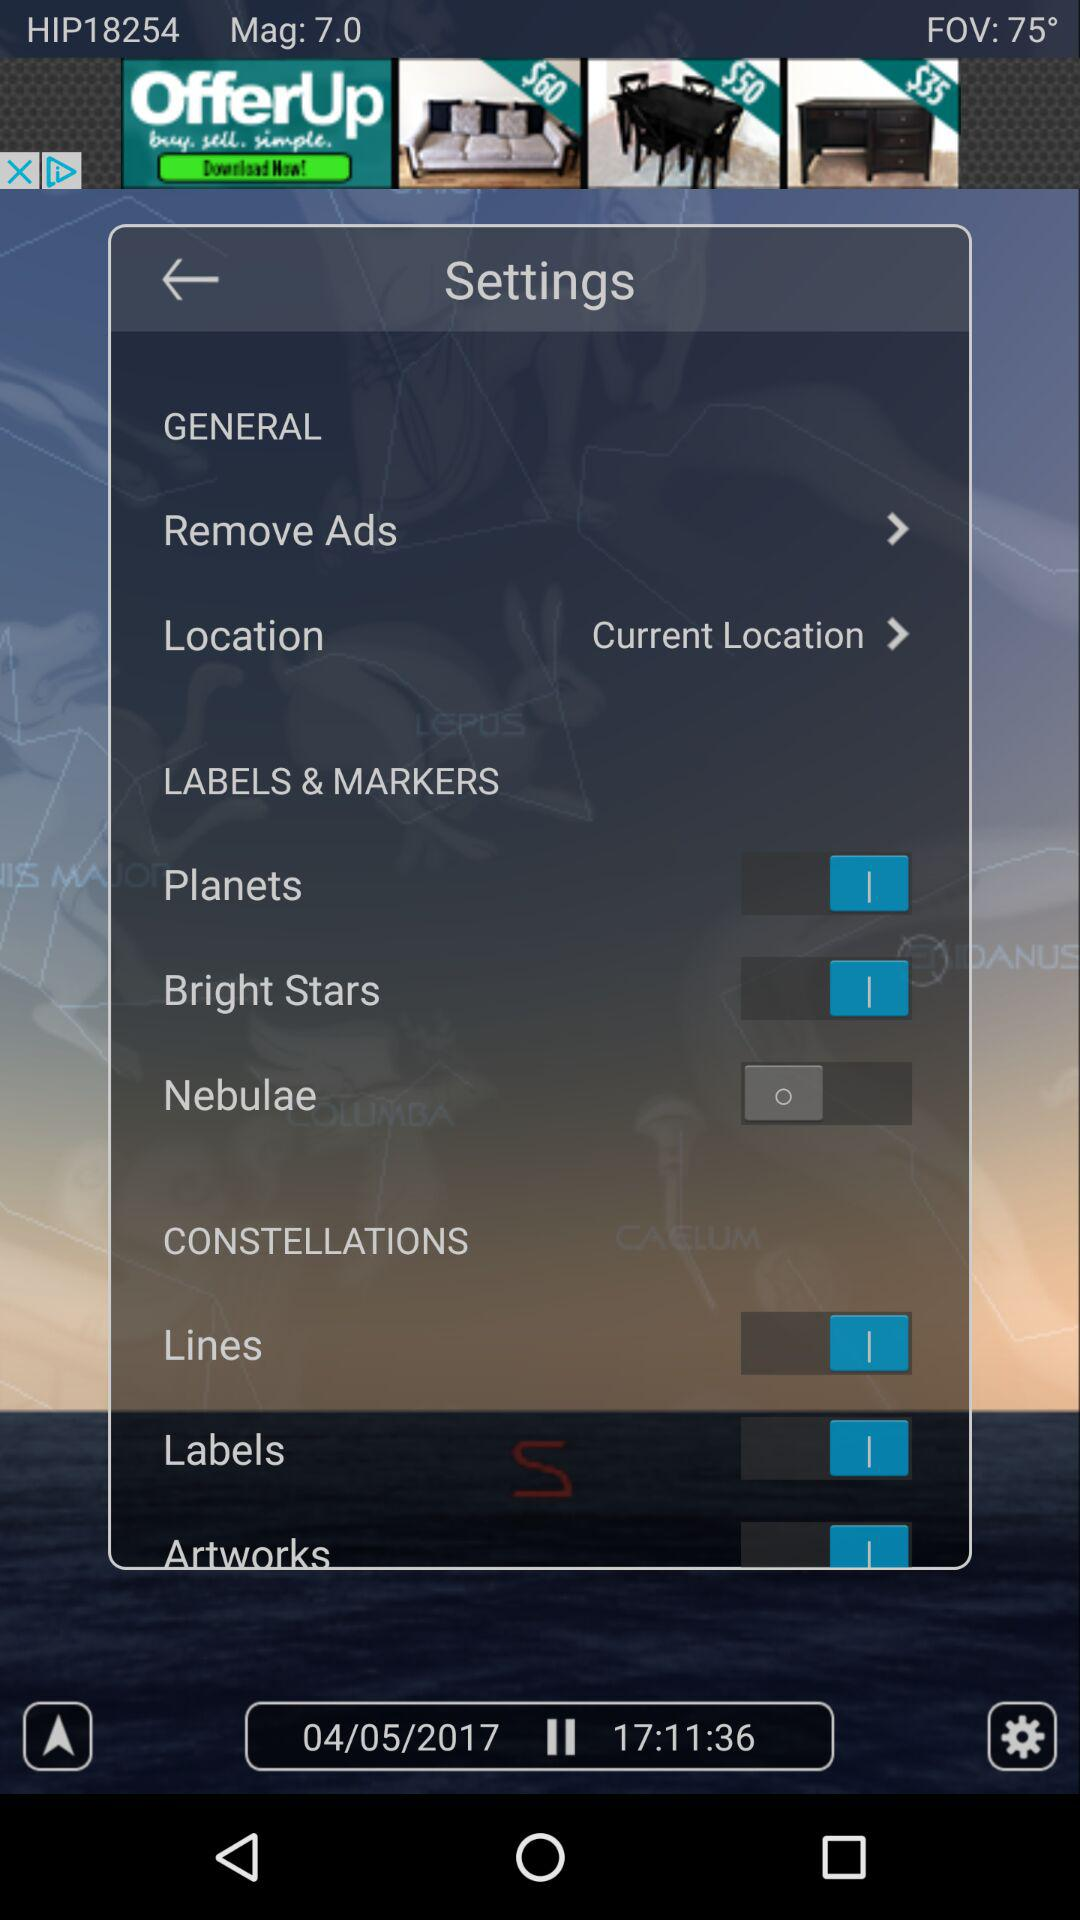What is the status of the "Planets"? The status is "on". 